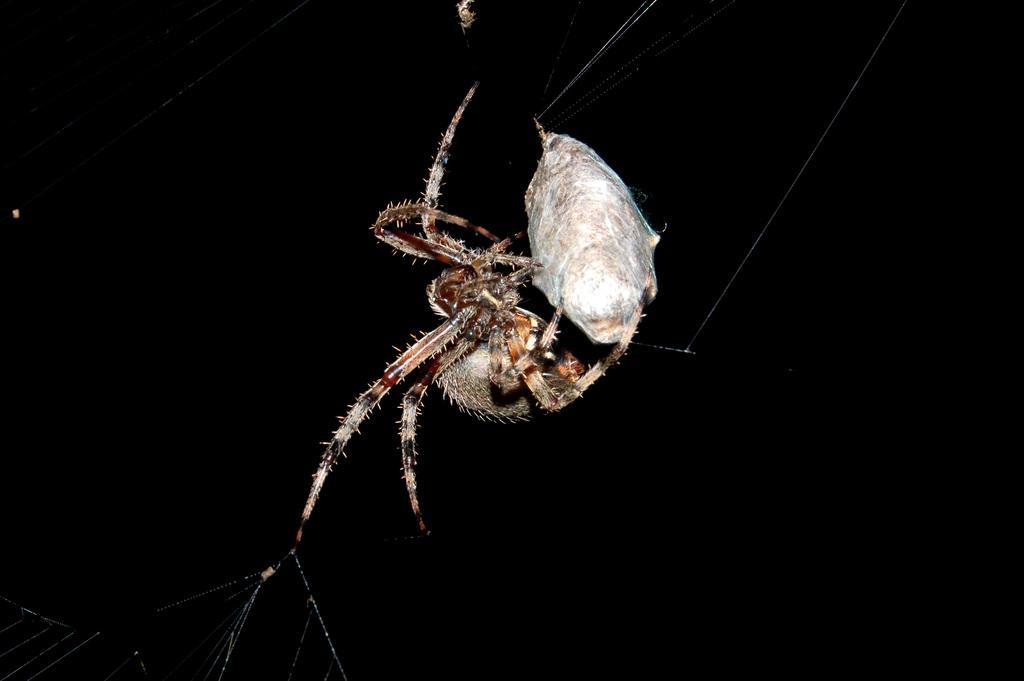In one or two sentences, can you explain what this image depicts? In this picture we can observe a spider. We can observe a web of a spider. The background is completely dark. 